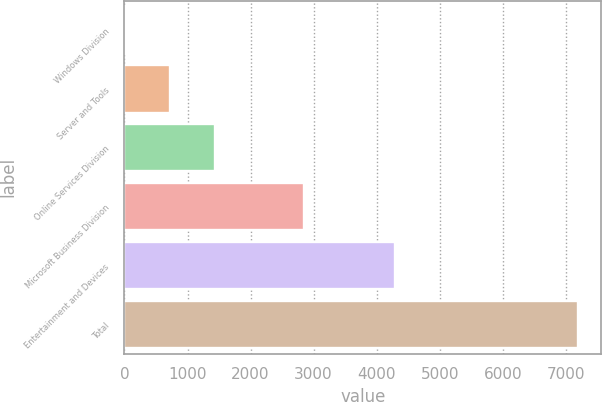<chart> <loc_0><loc_0><loc_500><loc_500><bar_chart><fcel>Windows Division<fcel>Server and Tools<fcel>Online Services Division<fcel>Microsoft Business Division<fcel>Entertainment and Devices<fcel>Total<nl><fcel>3.88<fcel>723.29<fcel>1442.7<fcel>2843<fcel>4294<fcel>7198<nl></chart> 